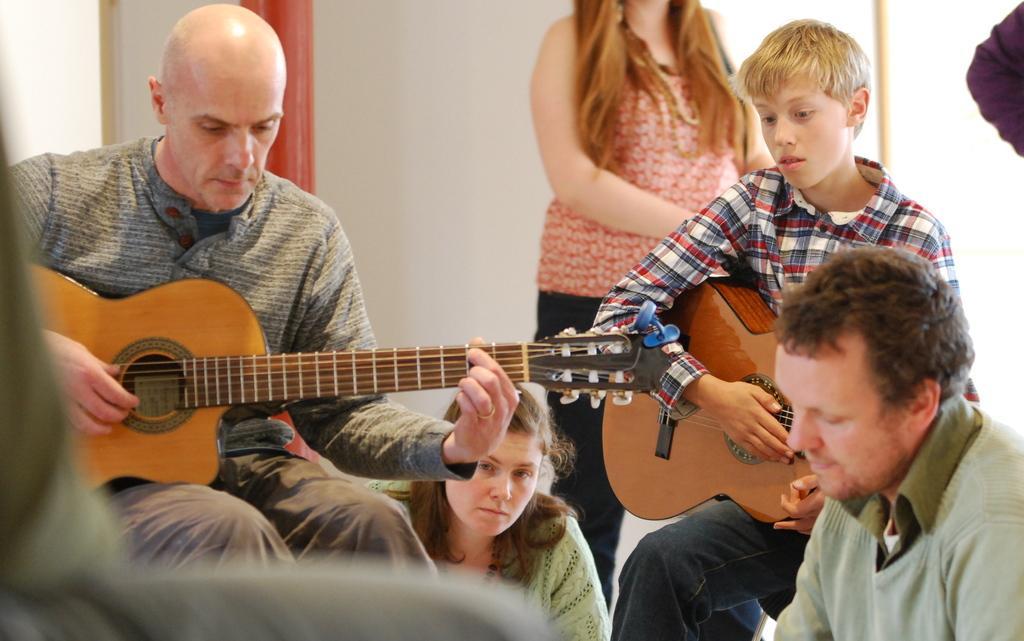How would you summarize this image in a sentence or two? This picture describes about group of people some are seated and some are standing, in the left side of the image a man is playing guitar, in the background we can see a wall and curtain. 